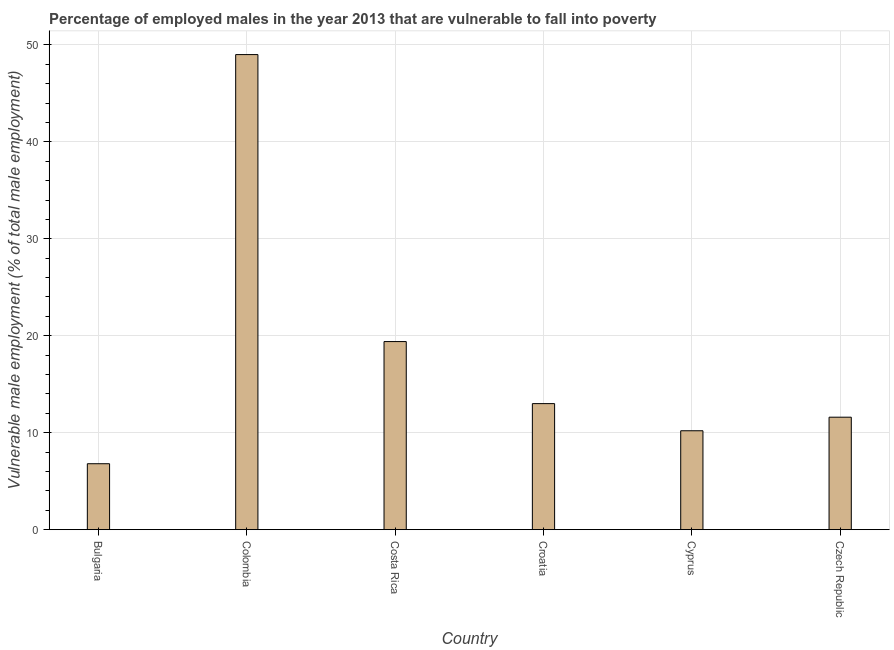Does the graph contain any zero values?
Keep it short and to the point. No. What is the title of the graph?
Provide a succinct answer. Percentage of employed males in the year 2013 that are vulnerable to fall into poverty. What is the label or title of the X-axis?
Provide a succinct answer. Country. What is the label or title of the Y-axis?
Offer a terse response. Vulnerable male employment (% of total male employment). What is the percentage of employed males who are vulnerable to fall into poverty in Cyprus?
Make the answer very short. 10.2. Across all countries, what is the minimum percentage of employed males who are vulnerable to fall into poverty?
Your answer should be compact. 6.8. In which country was the percentage of employed males who are vulnerable to fall into poverty minimum?
Give a very brief answer. Bulgaria. What is the sum of the percentage of employed males who are vulnerable to fall into poverty?
Offer a terse response. 110. What is the difference between the percentage of employed males who are vulnerable to fall into poverty in Bulgaria and Croatia?
Keep it short and to the point. -6.2. What is the average percentage of employed males who are vulnerable to fall into poverty per country?
Offer a very short reply. 18.33. What is the median percentage of employed males who are vulnerable to fall into poverty?
Your answer should be compact. 12.3. In how many countries, is the percentage of employed males who are vulnerable to fall into poverty greater than 20 %?
Provide a succinct answer. 1. What is the ratio of the percentage of employed males who are vulnerable to fall into poverty in Cyprus to that in Czech Republic?
Offer a terse response. 0.88. What is the difference between the highest and the second highest percentage of employed males who are vulnerable to fall into poverty?
Give a very brief answer. 29.6. Is the sum of the percentage of employed males who are vulnerable to fall into poverty in Colombia and Czech Republic greater than the maximum percentage of employed males who are vulnerable to fall into poverty across all countries?
Provide a short and direct response. Yes. What is the difference between the highest and the lowest percentage of employed males who are vulnerable to fall into poverty?
Make the answer very short. 42.2. In how many countries, is the percentage of employed males who are vulnerable to fall into poverty greater than the average percentage of employed males who are vulnerable to fall into poverty taken over all countries?
Provide a short and direct response. 2. Are all the bars in the graph horizontal?
Your answer should be compact. No. How many countries are there in the graph?
Offer a very short reply. 6. What is the difference between two consecutive major ticks on the Y-axis?
Offer a very short reply. 10. What is the Vulnerable male employment (% of total male employment) in Bulgaria?
Offer a terse response. 6.8. What is the Vulnerable male employment (% of total male employment) in Colombia?
Offer a very short reply. 49. What is the Vulnerable male employment (% of total male employment) in Costa Rica?
Give a very brief answer. 19.4. What is the Vulnerable male employment (% of total male employment) of Cyprus?
Give a very brief answer. 10.2. What is the Vulnerable male employment (% of total male employment) in Czech Republic?
Offer a terse response. 11.6. What is the difference between the Vulnerable male employment (% of total male employment) in Bulgaria and Colombia?
Provide a short and direct response. -42.2. What is the difference between the Vulnerable male employment (% of total male employment) in Bulgaria and Costa Rica?
Your answer should be very brief. -12.6. What is the difference between the Vulnerable male employment (% of total male employment) in Bulgaria and Croatia?
Make the answer very short. -6.2. What is the difference between the Vulnerable male employment (% of total male employment) in Bulgaria and Czech Republic?
Provide a succinct answer. -4.8. What is the difference between the Vulnerable male employment (% of total male employment) in Colombia and Costa Rica?
Offer a very short reply. 29.6. What is the difference between the Vulnerable male employment (% of total male employment) in Colombia and Croatia?
Provide a succinct answer. 36. What is the difference between the Vulnerable male employment (% of total male employment) in Colombia and Cyprus?
Offer a terse response. 38.8. What is the difference between the Vulnerable male employment (% of total male employment) in Colombia and Czech Republic?
Make the answer very short. 37.4. What is the difference between the Vulnerable male employment (% of total male employment) in Costa Rica and Croatia?
Your answer should be compact. 6.4. What is the difference between the Vulnerable male employment (% of total male employment) in Cyprus and Czech Republic?
Make the answer very short. -1.4. What is the ratio of the Vulnerable male employment (% of total male employment) in Bulgaria to that in Colombia?
Make the answer very short. 0.14. What is the ratio of the Vulnerable male employment (% of total male employment) in Bulgaria to that in Costa Rica?
Keep it short and to the point. 0.35. What is the ratio of the Vulnerable male employment (% of total male employment) in Bulgaria to that in Croatia?
Your response must be concise. 0.52. What is the ratio of the Vulnerable male employment (% of total male employment) in Bulgaria to that in Cyprus?
Offer a terse response. 0.67. What is the ratio of the Vulnerable male employment (% of total male employment) in Bulgaria to that in Czech Republic?
Your answer should be very brief. 0.59. What is the ratio of the Vulnerable male employment (% of total male employment) in Colombia to that in Costa Rica?
Keep it short and to the point. 2.53. What is the ratio of the Vulnerable male employment (% of total male employment) in Colombia to that in Croatia?
Make the answer very short. 3.77. What is the ratio of the Vulnerable male employment (% of total male employment) in Colombia to that in Cyprus?
Your answer should be compact. 4.8. What is the ratio of the Vulnerable male employment (% of total male employment) in Colombia to that in Czech Republic?
Offer a very short reply. 4.22. What is the ratio of the Vulnerable male employment (% of total male employment) in Costa Rica to that in Croatia?
Your answer should be very brief. 1.49. What is the ratio of the Vulnerable male employment (% of total male employment) in Costa Rica to that in Cyprus?
Offer a very short reply. 1.9. What is the ratio of the Vulnerable male employment (% of total male employment) in Costa Rica to that in Czech Republic?
Ensure brevity in your answer.  1.67. What is the ratio of the Vulnerable male employment (% of total male employment) in Croatia to that in Cyprus?
Give a very brief answer. 1.27. What is the ratio of the Vulnerable male employment (% of total male employment) in Croatia to that in Czech Republic?
Ensure brevity in your answer.  1.12. What is the ratio of the Vulnerable male employment (% of total male employment) in Cyprus to that in Czech Republic?
Offer a very short reply. 0.88. 